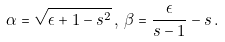<formula> <loc_0><loc_0><loc_500><loc_500>\alpha = \sqrt { \epsilon + 1 - s ^ { 2 } } \, , \, \beta = \frac { \epsilon } { s - 1 } - s \, .</formula> 